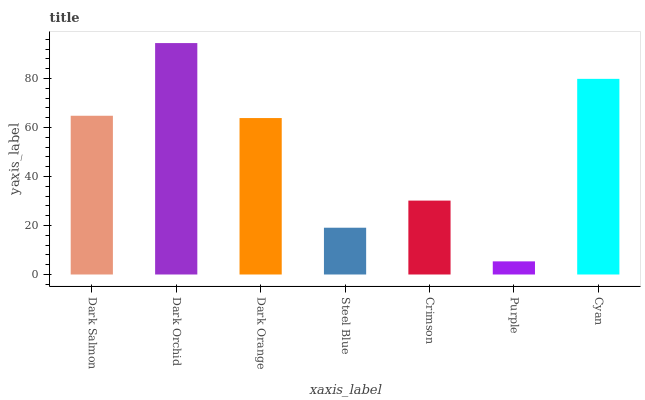Is Dark Orange the minimum?
Answer yes or no. No. Is Dark Orange the maximum?
Answer yes or no. No. Is Dark Orchid greater than Dark Orange?
Answer yes or no. Yes. Is Dark Orange less than Dark Orchid?
Answer yes or no. Yes. Is Dark Orange greater than Dark Orchid?
Answer yes or no. No. Is Dark Orchid less than Dark Orange?
Answer yes or no. No. Is Dark Orange the high median?
Answer yes or no. Yes. Is Dark Orange the low median?
Answer yes or no. Yes. Is Steel Blue the high median?
Answer yes or no. No. Is Purple the low median?
Answer yes or no. No. 